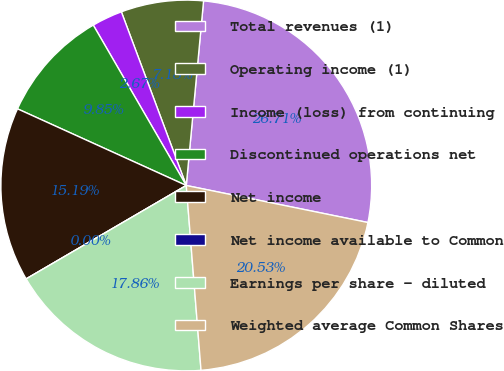<chart> <loc_0><loc_0><loc_500><loc_500><pie_chart><fcel>Total revenues (1)<fcel>Operating income (1)<fcel>Income (loss) from continuing<fcel>Discontinued operations net<fcel>Net income<fcel>Net income available to Common<fcel>Earnings per share - diluted<fcel>Weighted average Common Shares<nl><fcel>26.71%<fcel>7.18%<fcel>2.67%<fcel>9.85%<fcel>15.19%<fcel>0.0%<fcel>17.86%<fcel>20.53%<nl></chart> 